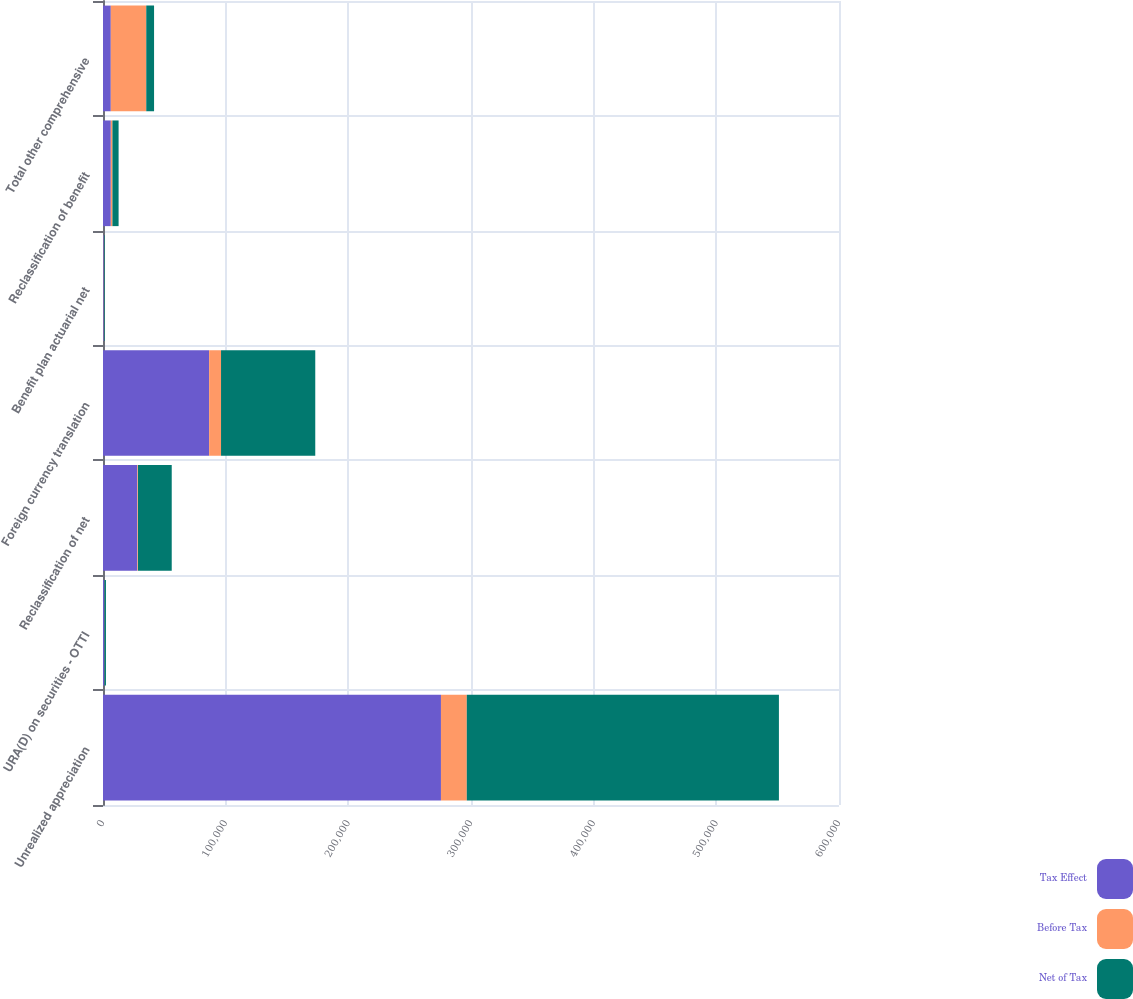<chart> <loc_0><loc_0><loc_500><loc_500><stacked_bar_chart><ecel><fcel>Unrealized appreciation<fcel>URA(D) on securities - OTTI<fcel>Reclassification of net<fcel>Foreign currency translation<fcel>Benefit plan actuarial net<fcel>Reclassification of benefit<fcel>Total other comprehensive<nl><fcel>Tax Effect<fcel>275511<fcel>1071<fcel>28014<fcel>86520<fcel>646<fcel>6356<fcel>6356<nl><fcel>Before Tax<fcel>21061<fcel>135<fcel>518<fcel>9704<fcel>136<fcel>1335<fcel>28913<nl><fcel>Net of Tax<fcel>254450<fcel>1206<fcel>27496<fcel>76816<fcel>510<fcel>5021<fcel>6356<nl></chart> 